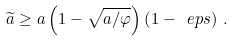<formula> <loc_0><loc_0><loc_500><loc_500>\widetilde { a } \geq a \left ( 1 - \sqrt { a / \varphi } \right ) \left ( 1 - \ e p s \right ) \, .</formula> 